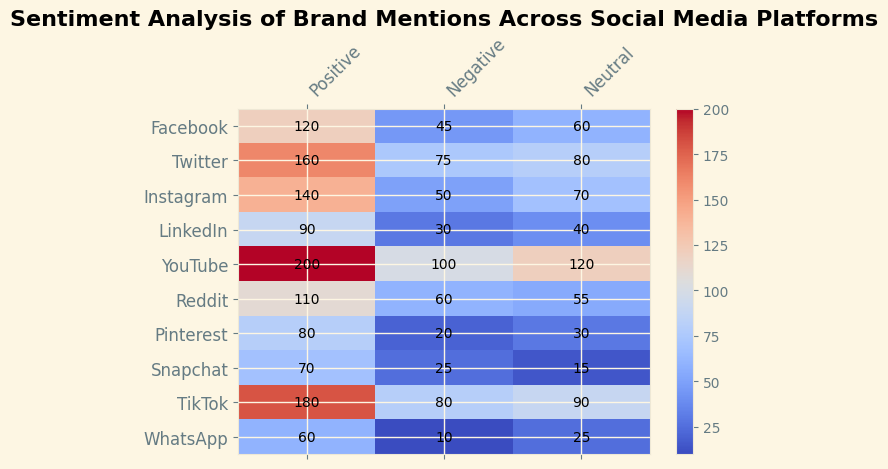Which platform has the highest number of positive sentiments? By carefully examining the heatmap, the color intensity, and the annotated values for positive sentiments, we identify that YouTube has the highest number of positive sentiments with a value of 200.
Answer: YouTube How many total mentions (sum of positive, negative, and neutral) does Instagram have? The values for Instagram are 140 (positive), 50 (negative), and 70 (neutral). Adding these values together, we get 140 + 50 + 70 = 260.
Answer: 260 Which platform has more negative mentions, Twitter or TikTok? By comparing the negative sentiment values from the heatmap, we see that Twitter has 75 negative mentions and TikTok has 80. Hence, TikTok has more negative mentions than Twitter.
Answer: TikTok What is the average number of sentiments for Facebook across all three categories (positive, negative, neutral)? The values for Facebook are 120 (positive), 45 (negative), and 60 (neutral). Summing these gives us 120 + 45 + 60 = 225. The average is then 225 / 3 = 75.
Answer: 75 Which sentiment category has the highest value on TikTok, and what is that value? Analyzing the sentiment values for TikTok, Positive (180), Negative (80), and Neutral (90), we find that the Positive category has the highest value at 180.
Answer: Positive, 180 How many platforms have more than 50 negative mentions? By counting the number of platforms with negative mentions greater than 50, we find that six platforms (Twitter, Instagram, YouTube, Reddit, TikTok) meet this condition.
Answer: Six Compare the total number of mentions on LinkedIn with Snapchat. Which platform has more, and by how many? LinkedIn has 90 (positive) + 30 (negative) + 40 (neutral) = 160 mentions. Snapchat has 70 (positive) + 25 (negative) + 15 (neutral) = 110 mentions. LinkedIn has 160 - 110 = 50 more mentions than Snapchat.
Answer: LinkedIn, 50 Which platform has the lowest number of neutral mentions? By examining the neutral sentiment values, WhatsApp has the lowest number with 25 neutral mentions.
Answer: WhatsApp Identify the platform with the least number of positive mentions and state the value. From the heatmap's positive sentiment values, WhatsApp has the least number of positive mentions with 60 mentions.
Answer: WhatsApp What is the total number of neutral mentions across all platforms? Summing the neutral mentions for all platforms: 60 (Facebook) + 80 (Twitter) + 70 (Instagram) + 40 (LinkedIn) + 120 (YouTube) + 55 (Reddit) + 30 (Pinterest) + 15 (Snapchat) + 90 (TikTok) + 25 (WhatsApp) = 585.
Answer: 585 